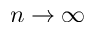<formula> <loc_0><loc_0><loc_500><loc_500>n \to \infty</formula> 